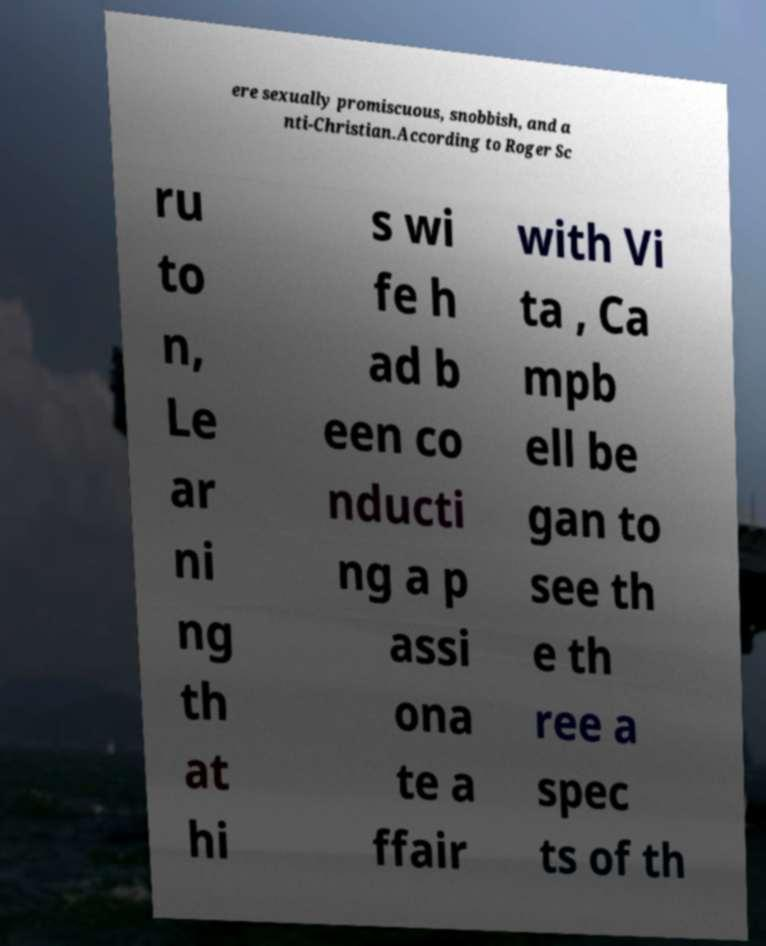Can you read and provide the text displayed in the image?This photo seems to have some interesting text. Can you extract and type it out for me? ere sexually promiscuous, snobbish, and a nti-Christian.According to Roger Sc ru to n, Le ar ni ng th at hi s wi fe h ad b een co nducti ng a p assi ona te a ffair with Vi ta , Ca mpb ell be gan to see th e th ree a spec ts of th 